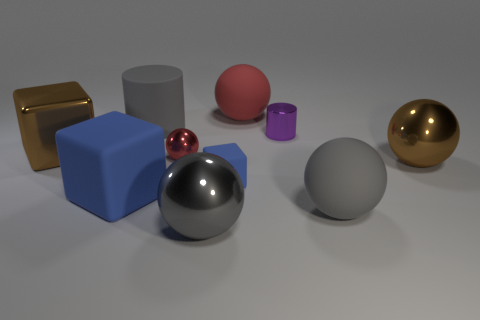There is another blue object that is the same shape as the small blue thing; what material is it?
Your answer should be very brief. Rubber. How many other things are there of the same color as the big rubber cube?
Give a very brief answer. 1. What is the material of the large cube that is behind the small blue block that is to the right of the large blue cube?
Your answer should be very brief. Metal. Are there any rubber spheres?
Keep it short and to the point. Yes. How big is the brown thing that is behind the brown metallic ball that is on the right side of the brown shiny block?
Make the answer very short. Large. Is the number of small purple metallic objects behind the brown shiny cube greater than the number of blocks on the left side of the small red shiny ball?
Ensure brevity in your answer.  No. How many balls are blue rubber objects or tiny metal things?
Keep it short and to the point. 1. Does the large gray matte thing that is in front of the brown metal ball have the same shape as the red matte thing?
Offer a terse response. Yes. The big cylinder has what color?
Give a very brief answer. Gray. What color is the other matte thing that is the same shape as the big blue thing?
Your answer should be very brief. Blue. 